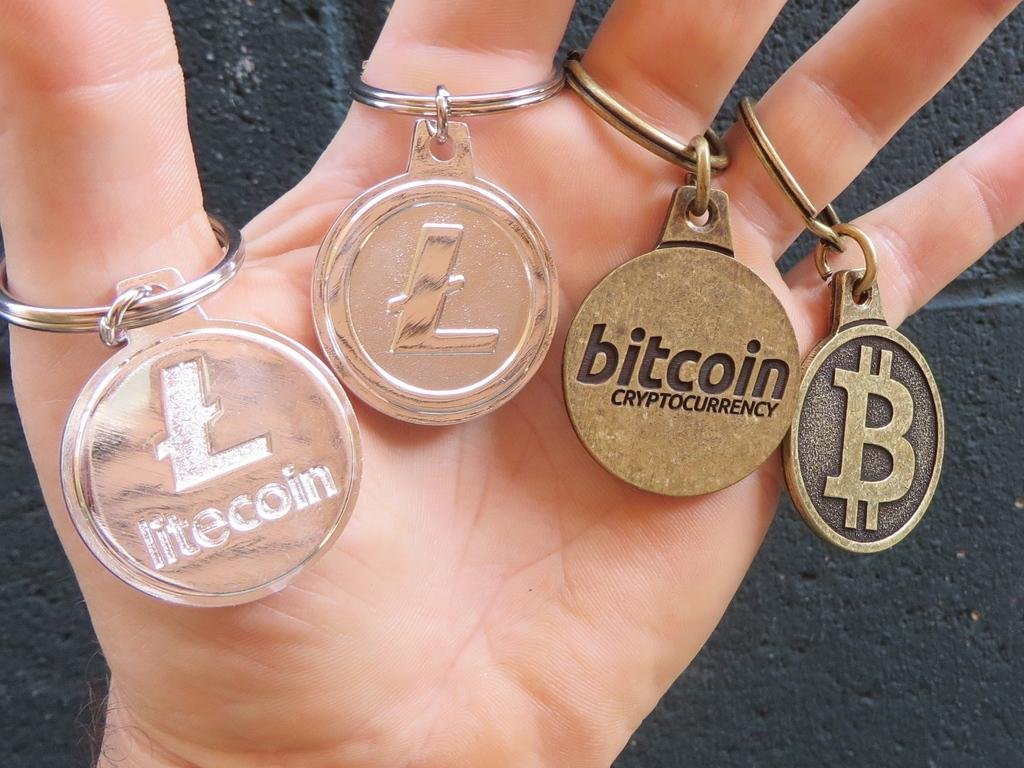Provide a one-sentence caption for the provided image. Hand holding four keychains including Bitcoin and litecoin. 